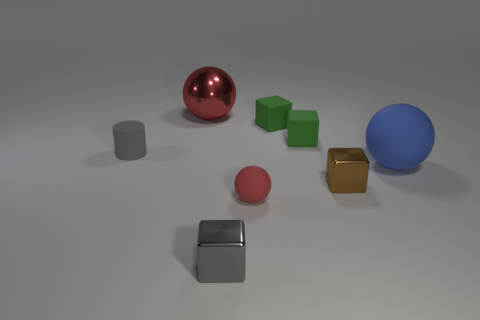Subtract all blue spheres. How many spheres are left? 2 Subtract all brown cubes. How many red balls are left? 2 Subtract 1 blocks. How many blocks are left? 3 Add 1 big yellow objects. How many objects exist? 9 Subtract all red spheres. How many spheres are left? 1 Subtract all tiny green cubes. Subtract all matte things. How many objects are left? 1 Add 7 large shiny things. How many large shiny things are left? 8 Add 8 big red cylinders. How many big red cylinders exist? 8 Subtract 1 brown blocks. How many objects are left? 7 Subtract all balls. How many objects are left? 5 